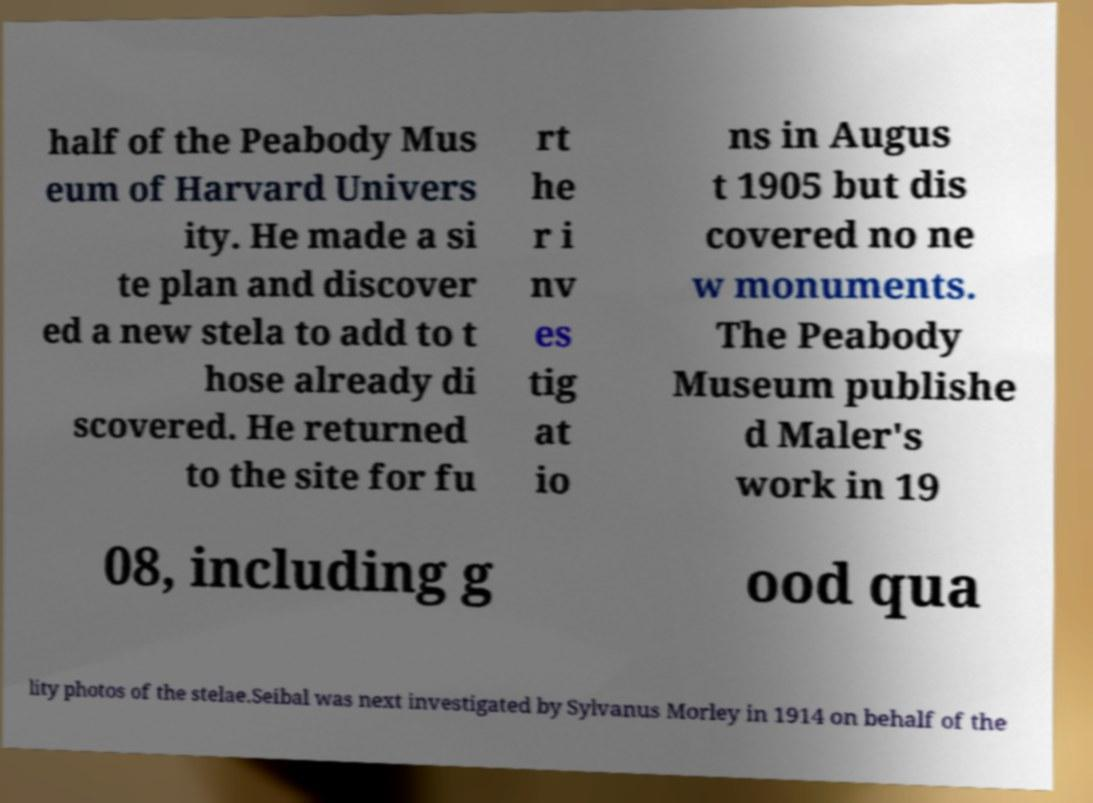I need the written content from this picture converted into text. Can you do that? half of the Peabody Mus eum of Harvard Univers ity. He made a si te plan and discover ed a new stela to add to t hose already di scovered. He returned to the site for fu rt he r i nv es tig at io ns in Augus t 1905 but dis covered no ne w monuments. The Peabody Museum publishe d Maler's work in 19 08, including g ood qua lity photos of the stelae.Seibal was next investigated by Sylvanus Morley in 1914 on behalf of the 